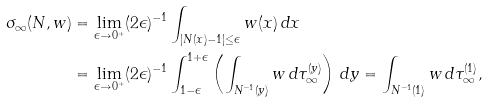<formula> <loc_0><loc_0><loc_500><loc_500>\sigma _ { \infty } ( N , w ) & = \lim _ { \epsilon \to 0 ^ { + } } ( 2 \epsilon ) ^ { - 1 } \int _ { | N ( x ) - 1 | \leq \epsilon } w ( x ) \, d x \\ & = \lim _ { \epsilon \to 0 ^ { + } } ( 2 \epsilon ) ^ { - 1 } \int _ { 1 - \epsilon } ^ { 1 + \epsilon } \left ( \int _ { N ^ { - 1 } ( y ) } w \, d \tau ^ { ( y ) } _ { \infty } \right ) \, d y = \int _ { N ^ { - 1 } ( 1 ) } w \, d \tau ^ { ( 1 ) } _ { \infty } ,</formula> 